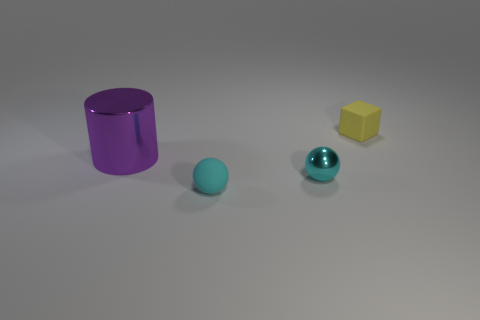Add 1 big red things. How many objects exist? 5 Subtract all cubes. How many objects are left? 3 Add 1 cyan rubber things. How many cyan rubber things exist? 2 Subtract 0 brown cubes. How many objects are left? 4 Subtract all tiny blue metal balls. Subtract all cyan metal spheres. How many objects are left? 3 Add 4 cyan metallic balls. How many cyan metallic balls are left? 5 